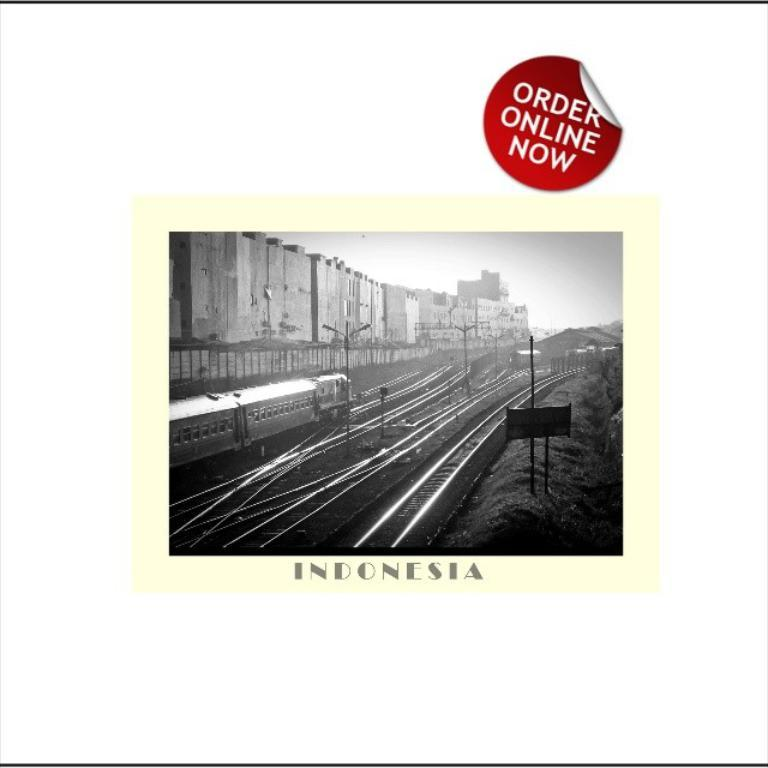<image>
Provide a brief description of the given image. A black and white photo of Indonesia says that it can be ordered online now. 